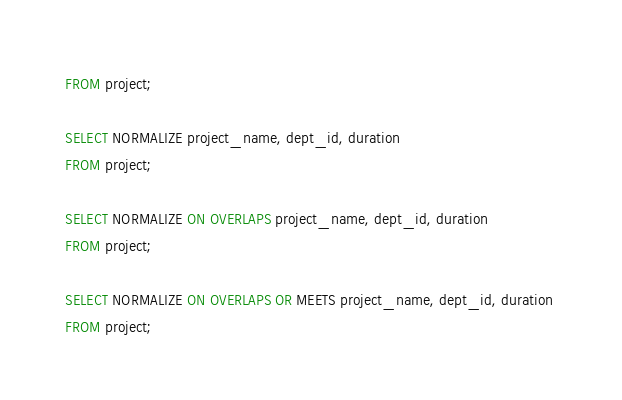Convert code to text. <code><loc_0><loc_0><loc_500><loc_500><_SQL_>FROM project;

SELECT NORMALIZE project_name, dept_id, duration 
FROM project;

SELECT NORMALIZE ON OVERLAPS project_name, dept_id, duration 
FROM project;

SELECT NORMALIZE ON OVERLAPS OR MEETS project_name, dept_id, duration 
FROM project;
</code> 